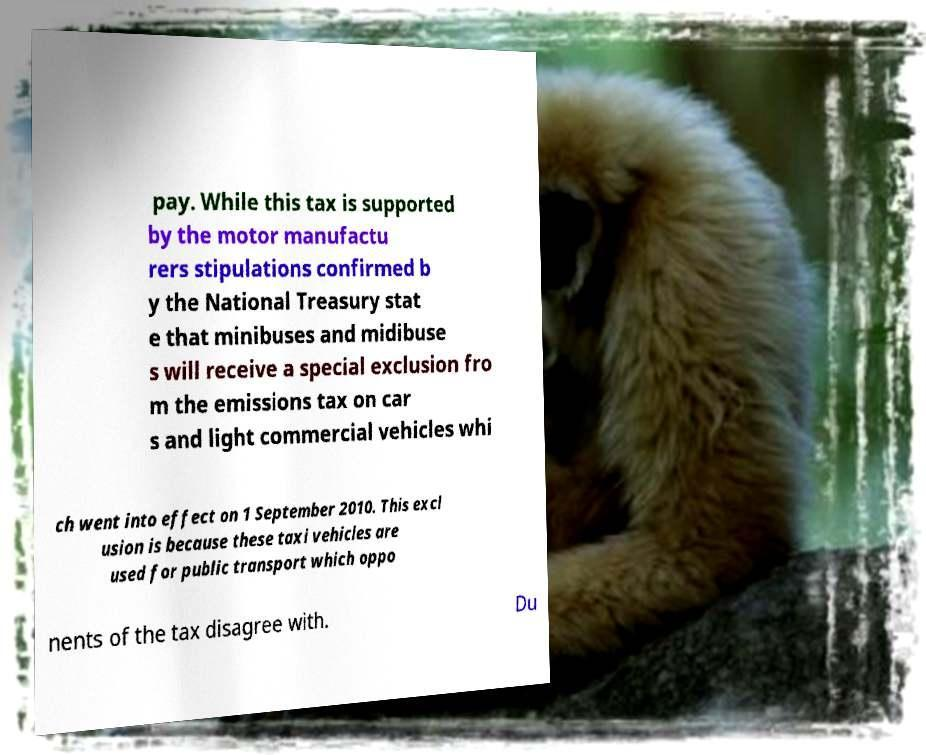Can you read and provide the text displayed in the image?This photo seems to have some interesting text. Can you extract and type it out for me? pay. While this tax is supported by the motor manufactu rers stipulations confirmed b y the National Treasury stat e that minibuses and midibuse s will receive a special exclusion fro m the emissions tax on car s and light commercial vehicles whi ch went into effect on 1 September 2010. This excl usion is because these taxi vehicles are used for public transport which oppo nents of the tax disagree with. Du 